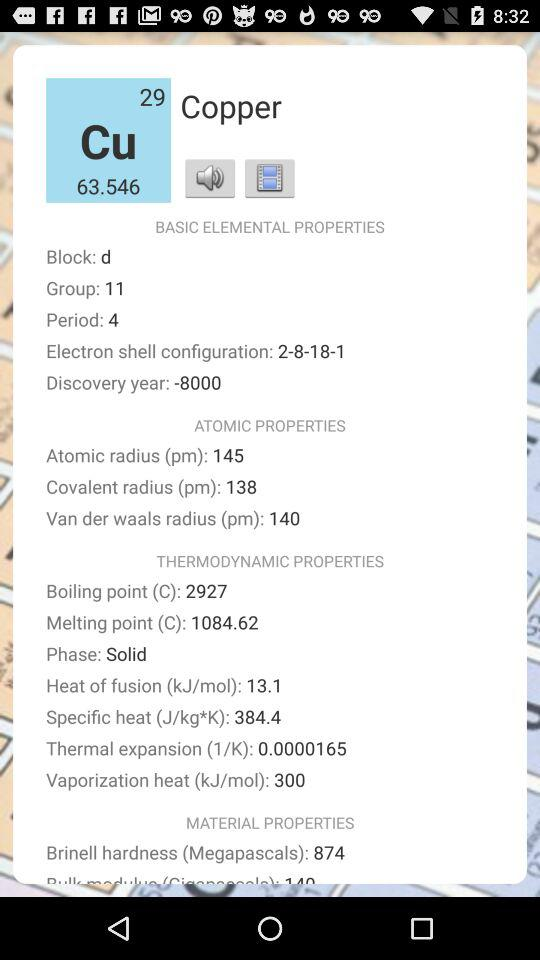What is the covalent radius? The covalent radius is 138 pm. 